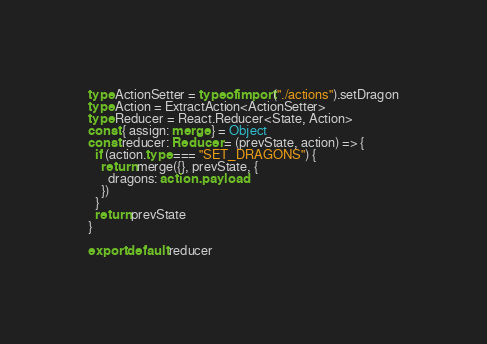Convert code to text. <code><loc_0><loc_0><loc_500><loc_500><_TypeScript_>type ActionSetter = typeof import("./actions").setDragon
type Action = ExtractAction<ActionSetter>
type Reducer = React.Reducer<State, Action>
const { assign: merge } = Object
const reducer: Reducer = (prevState, action) => {
  if (action.type === "SET_DRAGONS") {
    return merge({}, prevState, {
      dragons: action.payload
    })
  }
  return prevState
}

export default reducer
</code> 